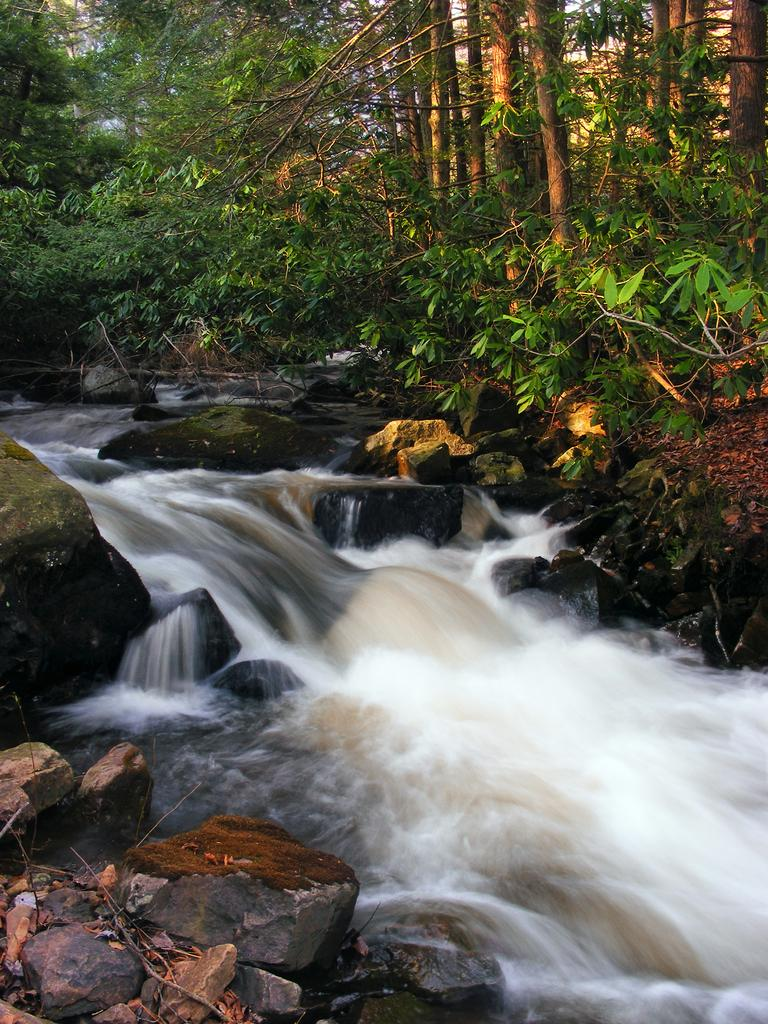What is the primary element in the image? There is water in the image. Can you describe the water in the image? The water might be a tributary of a river. What can be seen at the bottom of the image? There are stones, twigs, and rocks at the bottom of the image. What is visible in the background of the image? There are trees in the background of the image. What type of jewel can be seen sparkling in the water in the image? There is no jewel present in the image; it features water with stones, twigs, and rocks at the bottom. Is there a camera visible in the image? There is no camera present in the image. 